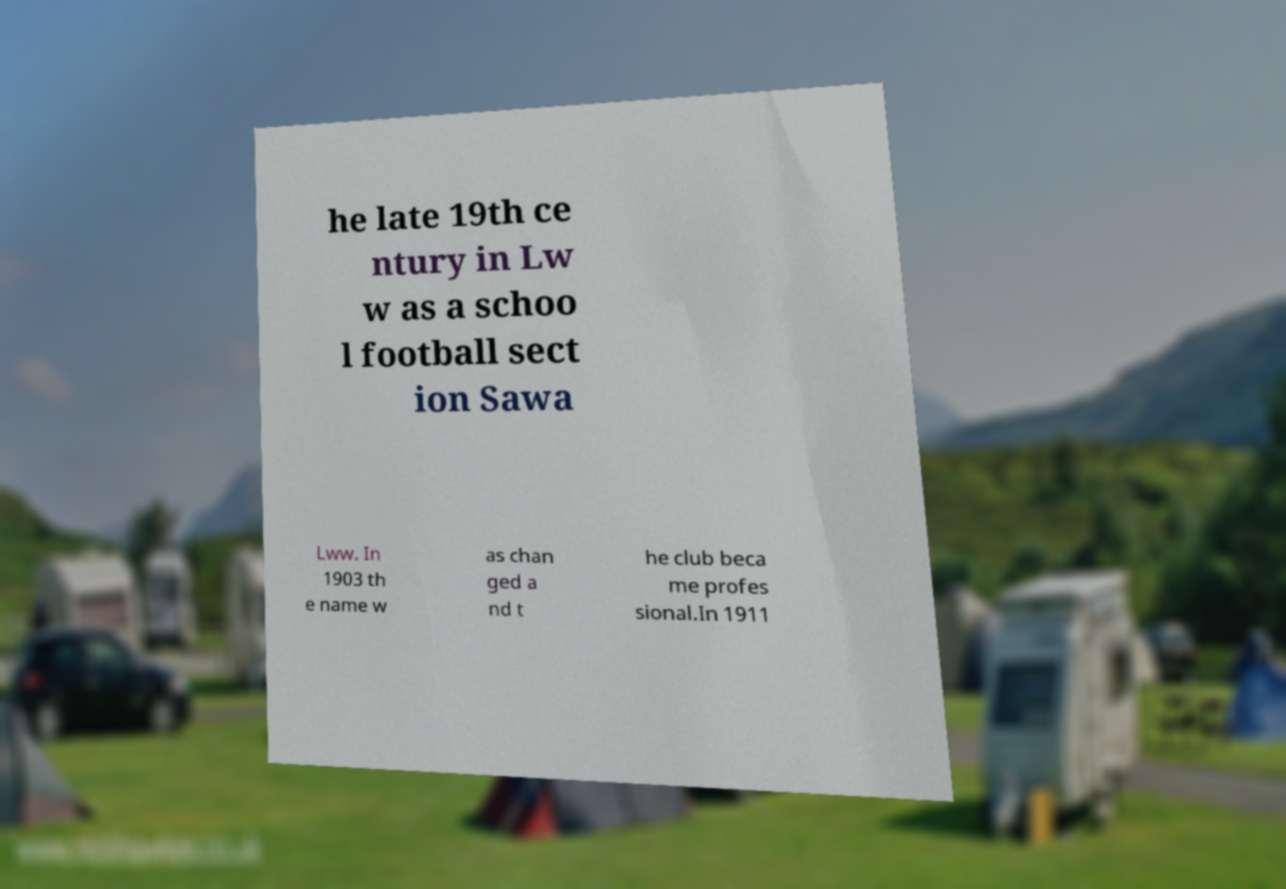For documentation purposes, I need the text within this image transcribed. Could you provide that? he late 19th ce ntury in Lw w as a schoo l football sect ion Sawa Lww. In 1903 th e name w as chan ged a nd t he club beca me profes sional.In 1911 